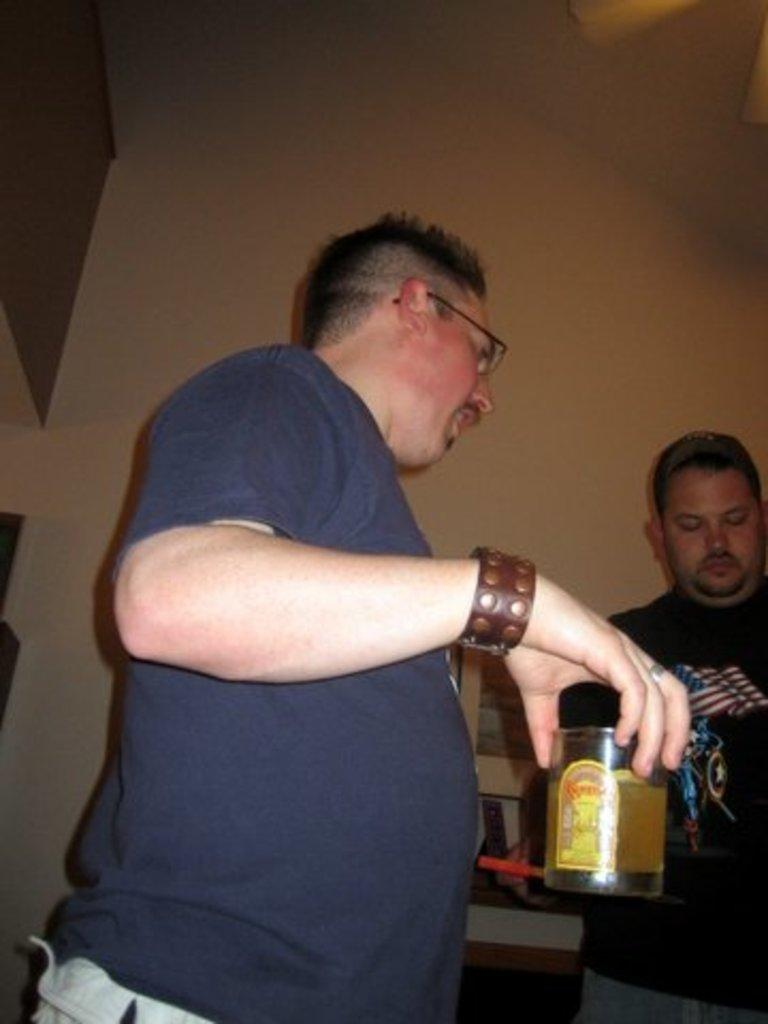What is the man in the image doing? There is a man standing in the image. What is the man holding in the image? The man is holding a glass with liquid. Can you describe the second person in the image? There is another person standing beside the first man, and they are wearing a black t-shirt. How is the first man dressed in the image? The first man is wearing a blue t-shirt and spectacles. What is the daughter of the man in the image doing? There is no mention of a daughter in the image or the provided facts. 